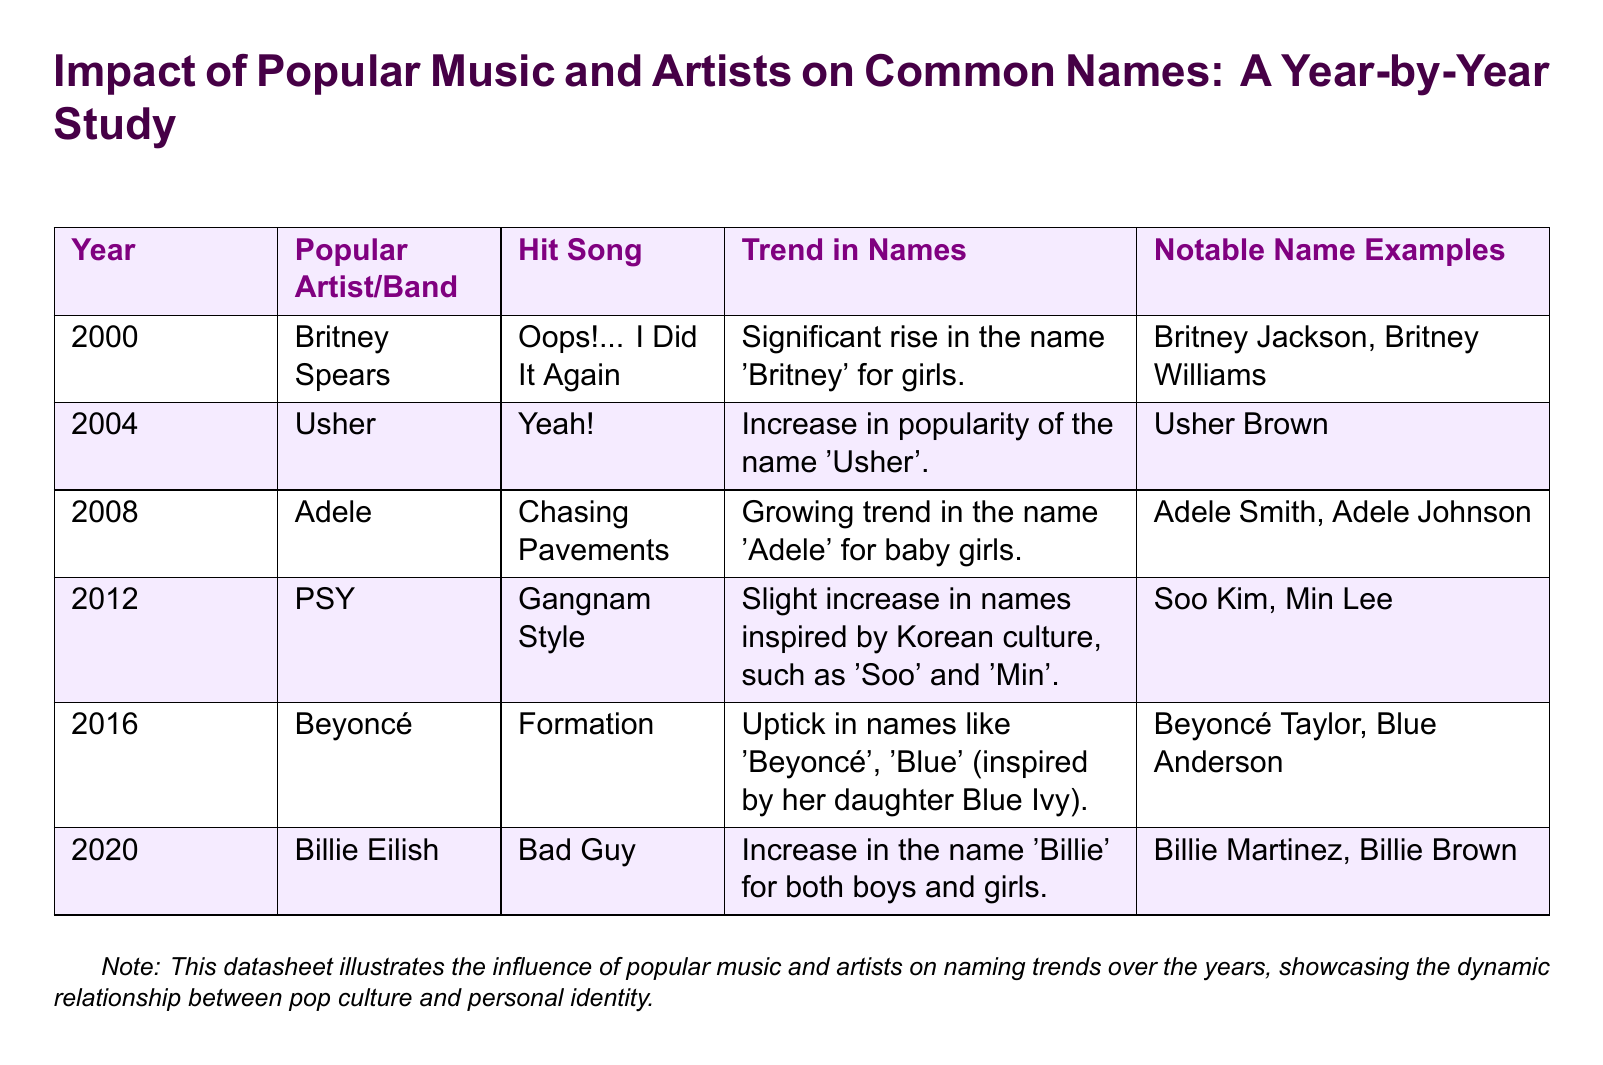What is the first year mentioned in the datasheet? The first year listed in the document is 2000.
Answer: 2000 Which artist's song is associated with the name 'Adele'? 'Chasing Pavements' by Adele is noted for the name trend.
Answer: Adele What notable name examples are provided for Usher? The document lists the notable name 'Usher Brown'.
Answer: Usher Brown In which year did the name 'Billie' see an increase? The name 'Billie' saw an increase in 2020 due to Billie Eilish.
Answer: 2020 What was the trend in names associated with Beyoncé's song 'Formation'? The trend included an uptick in names like 'Beyoncé' and 'Blue'.
Answer: 'Beyoncé', 'Blue' Which popular music artist had a song that led to a slight increase in Korean names? PSY had a song that inspired this trend.
Answer: PSY How many notable name examples are listed for Billie Eilish? There are two notable examples given for Billie Eilish: Billie Martinez and Billie Brown.
Answer: Two What color is used for the header in the table? The header color is defined in the document as purple.
Answer: Purple Which song is linked to the name trend for Britney? 'Oops!... I Did It Again' is linked to the name trend for Britney.
Answer: Oops!... I Did It Again 